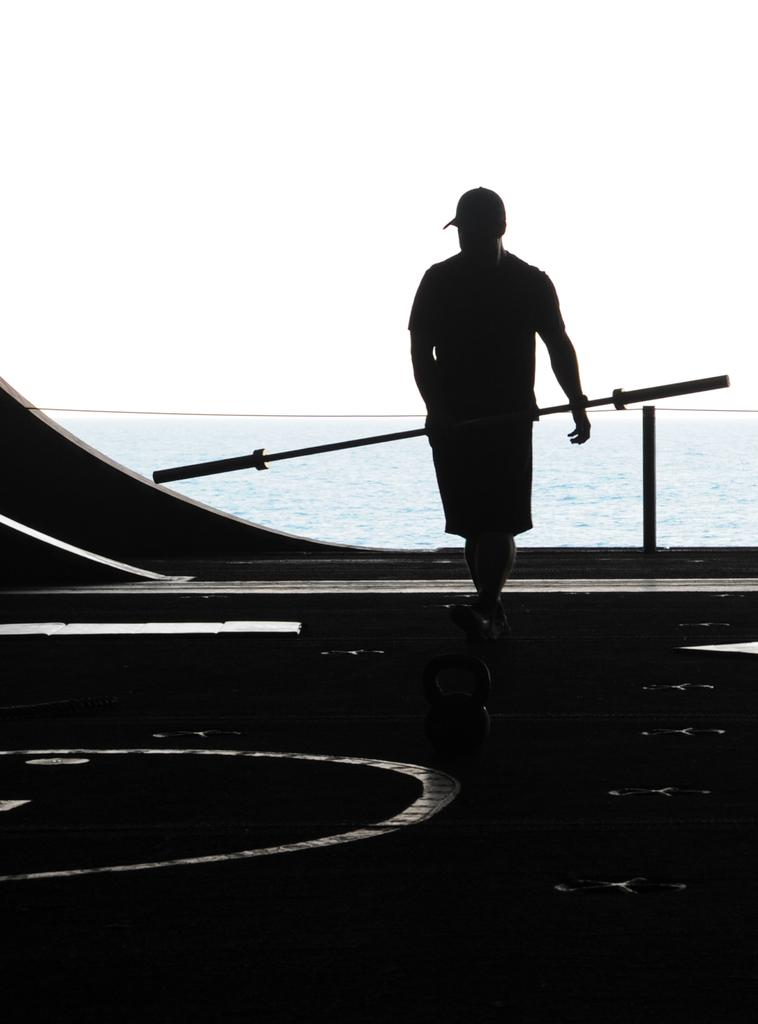What is the main subject of the picture? The main subject of the picture is a man. What is the man holding in the picture? The man is holding a rake. What can be seen in the background of the picture? There is an ocean in the background of the picture. What is visible at the top of the picture? The sky is visible at the top of the picture. How many ladybugs can be seen crawling on the rake in the image? There are no ladybugs present in the image, and therefore no such activity can be observed. Can you tell me how many fish are swimming in the ocean in the image? The image only shows the ocean in the background, but it does not depict any fish swimming in it. 